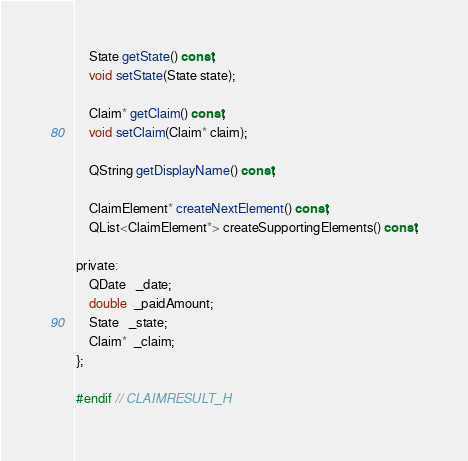<code> <loc_0><loc_0><loc_500><loc_500><_C_>    State getState() const;
    void setState(State state);

    Claim* getClaim() const;
    void setClaim(Claim* claim);

    QString getDisplayName() const;

    ClaimElement* createNextElement() const;
    QList<ClaimElement*> createSupportingElements() const;

private:
    QDate   _date;
    double  _paidAmount;
    State   _state;
    Claim*  _claim;
};

#endif // CLAIMRESULT_H
</code> 